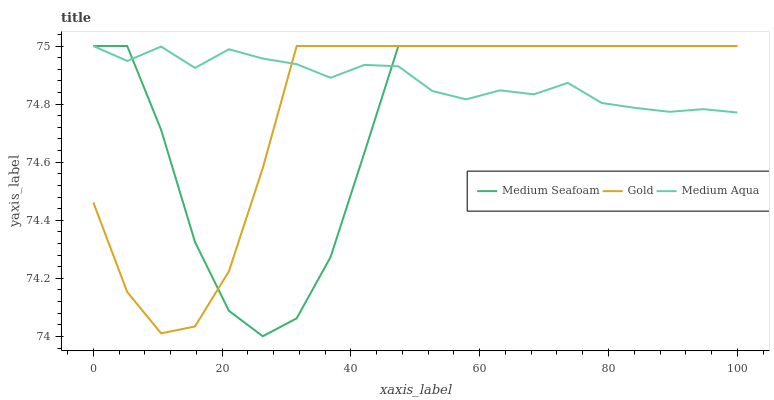Does Medium Seafoam have the minimum area under the curve?
Answer yes or no. Yes. Does Medium Aqua have the maximum area under the curve?
Answer yes or no. Yes. Does Gold have the minimum area under the curve?
Answer yes or no. No. Does Gold have the maximum area under the curve?
Answer yes or no. No. Is Medium Aqua the smoothest?
Answer yes or no. Yes. Is Medium Seafoam the roughest?
Answer yes or no. Yes. Is Gold the smoothest?
Answer yes or no. No. Is Gold the roughest?
Answer yes or no. No. Does Medium Seafoam have the lowest value?
Answer yes or no. Yes. Does Gold have the lowest value?
Answer yes or no. No. Does Gold have the highest value?
Answer yes or no. Yes. Does Medium Seafoam intersect Medium Aqua?
Answer yes or no. Yes. Is Medium Seafoam less than Medium Aqua?
Answer yes or no. No. Is Medium Seafoam greater than Medium Aqua?
Answer yes or no. No. 